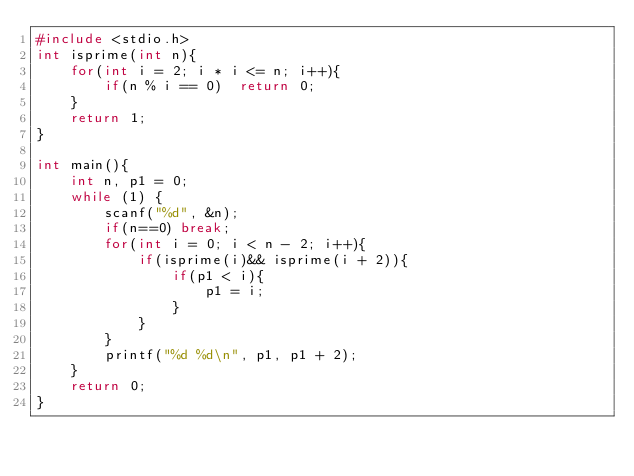Convert code to text. <code><loc_0><loc_0><loc_500><loc_500><_C_>#include <stdio.h>
int isprime(int n){
    for(int i = 2; i * i <= n; i++){
        if(n % i == 0)  return 0;
    }
    return 1;
}

int main(){
    int n, p1 = 0;
    while (1) {
        scanf("%d", &n);
        if(n==0) break;
        for(int i = 0; i < n - 2; i++){
            if(isprime(i)&& isprime(i + 2)){
                if(p1 < i){
                    p1 = i;
                }
            }
        }
        printf("%d %d\n", p1, p1 + 2);
    }
    return 0;
}</code> 